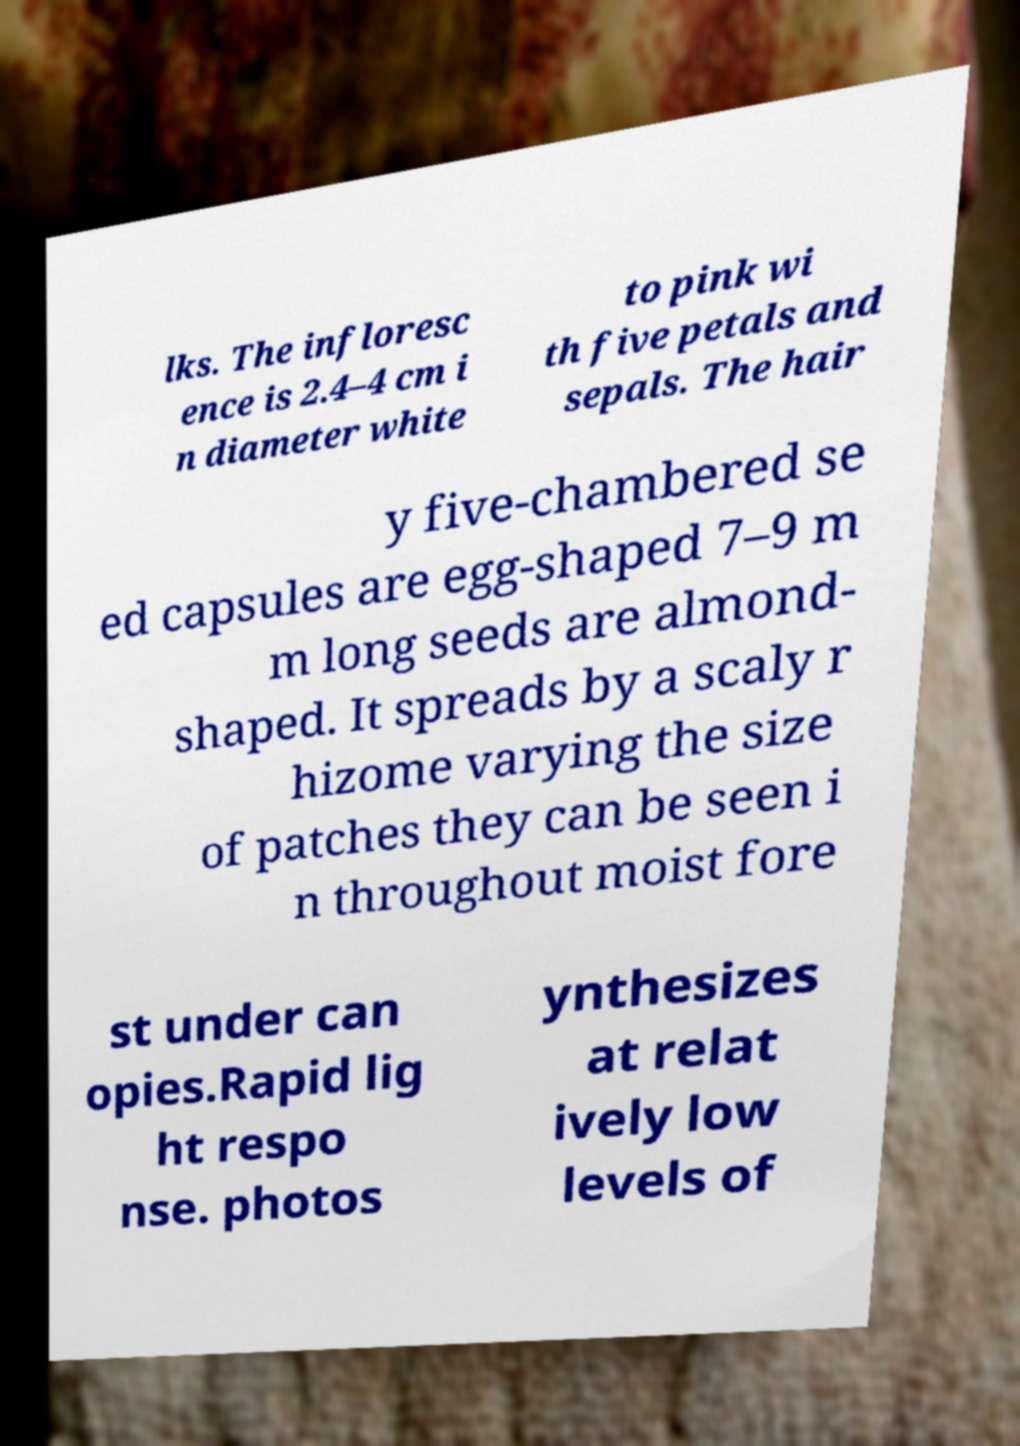Can you accurately transcribe the text from the provided image for me? lks. The infloresc ence is 2.4–4 cm i n diameter white to pink wi th five petals and sepals. The hair y five-chambered se ed capsules are egg-shaped 7–9 m m long seeds are almond- shaped. It spreads by a scaly r hizome varying the size of patches they can be seen i n throughout moist fore st under can opies.Rapid lig ht respo nse. photos ynthesizes at relat ively low levels of 